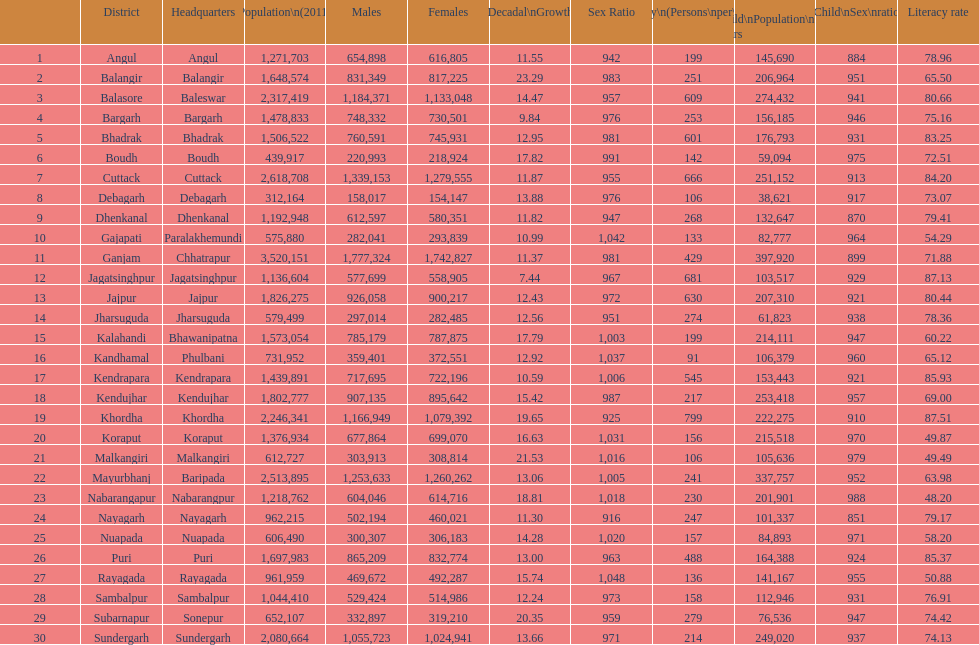What is the difference in child population between koraput and puri? 51,130. 